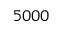<formula> <loc_0><loc_0><loc_500><loc_500>5 0 0 0</formula> 